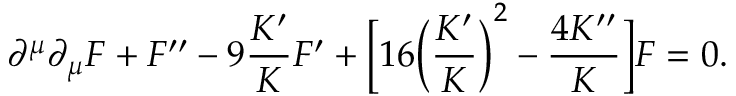Convert formula to latex. <formula><loc_0><loc_0><loc_500><loc_500>\partial ^ { \mu } \partial _ { \mu } F + F ^ { \prime \prime } - 9 \frac { K ^ { \prime } } { K } F ^ { \prime } + \left [ 1 6 \left ( \frac { K ^ { \prime } } { K } \right ) ^ { 2 } - \frac { 4 K ^ { \prime \prime } } { K } \right ] F = 0 .</formula> 